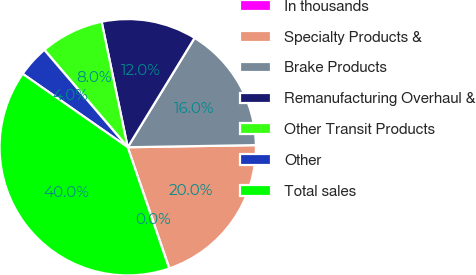<chart> <loc_0><loc_0><loc_500><loc_500><pie_chart><fcel>In thousands<fcel>Specialty Products &<fcel>Brake Products<fcel>Remanufacturing Overhaul &<fcel>Other Transit Products<fcel>Other<fcel>Total sales<nl><fcel>0.03%<fcel>19.99%<fcel>16.0%<fcel>12.0%<fcel>8.01%<fcel>4.02%<fcel>39.95%<nl></chart> 